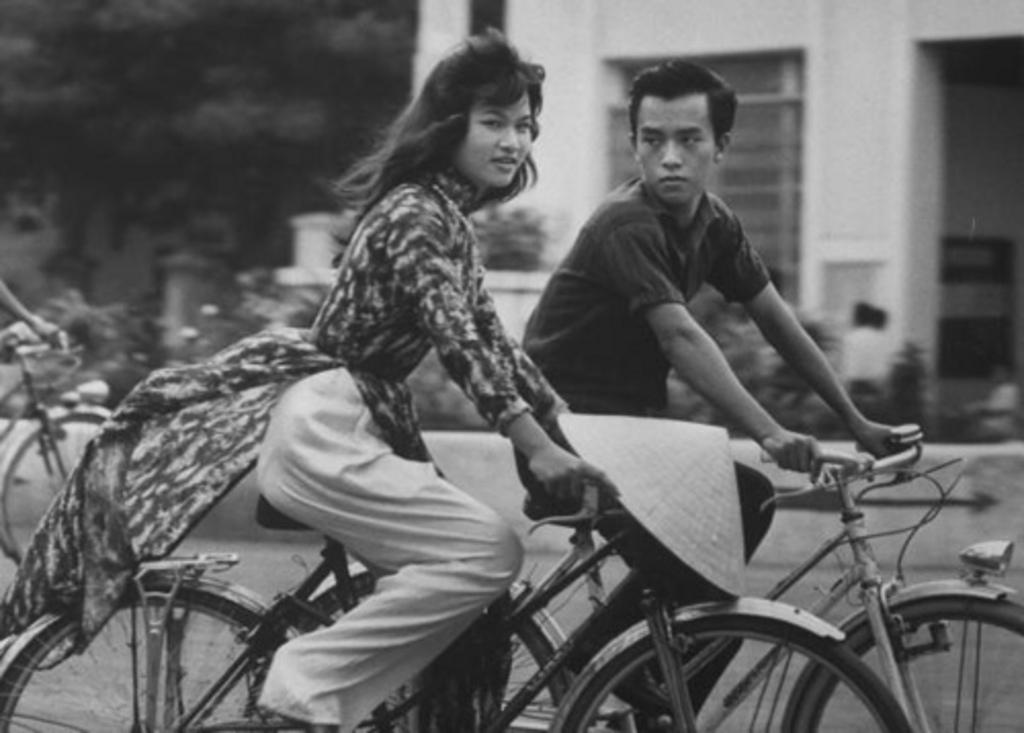What is the color scheme of the image? The image is black and white. What are the two people in the image doing? There is a woman and a man on bicycles in the image. What can be seen in the background of the image? There is a building in the background of the image. What type of vegetation is present in the image? There is a tree and plants in the image. What type of eggnog can be seen in the image? There is no eggnog present in the image. What color is the button on the woman's bicycle? There is no button mentioned on the woman's bicycle in the image. 